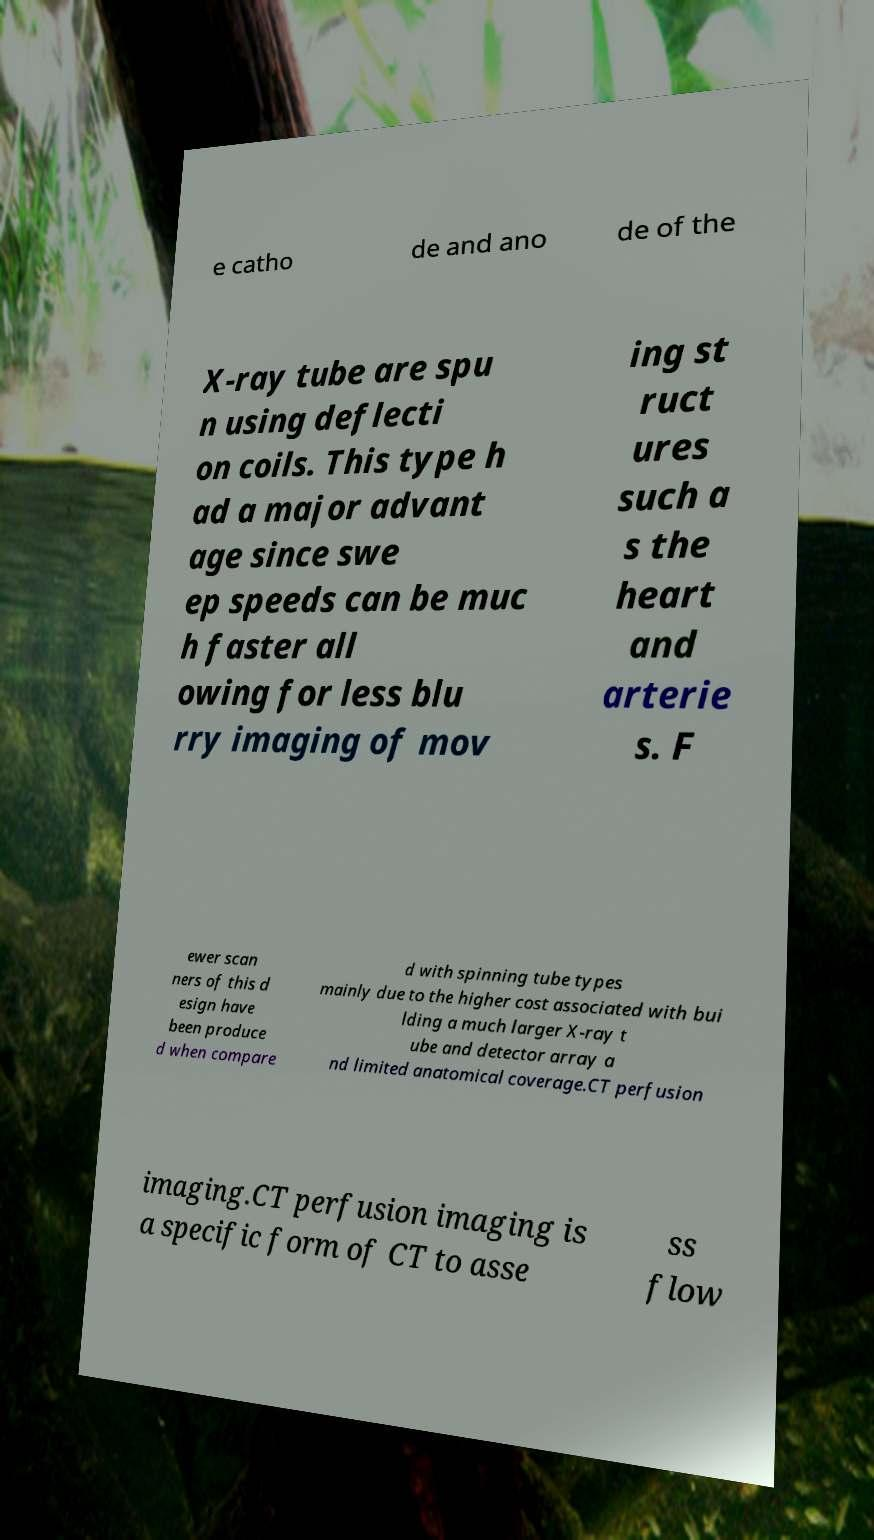Can you read and provide the text displayed in the image?This photo seems to have some interesting text. Can you extract and type it out for me? e catho de and ano de of the X-ray tube are spu n using deflecti on coils. This type h ad a major advant age since swe ep speeds can be muc h faster all owing for less blu rry imaging of mov ing st ruct ures such a s the heart and arterie s. F ewer scan ners of this d esign have been produce d when compare d with spinning tube types mainly due to the higher cost associated with bui lding a much larger X-ray t ube and detector array a nd limited anatomical coverage.CT perfusion imaging.CT perfusion imaging is a specific form of CT to asse ss flow 